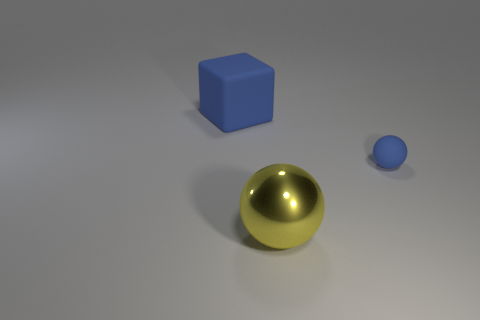What is the reflective quality of the sphere and how does it compare to the other objects? The sphere has a polished, shiny surface that reflects light sharply, indicating that it's likely made out of a metallic material like gold or brass. This contrasts with the matte surface of the other objects, suggesting they are made from different materials with less reflective properties. 